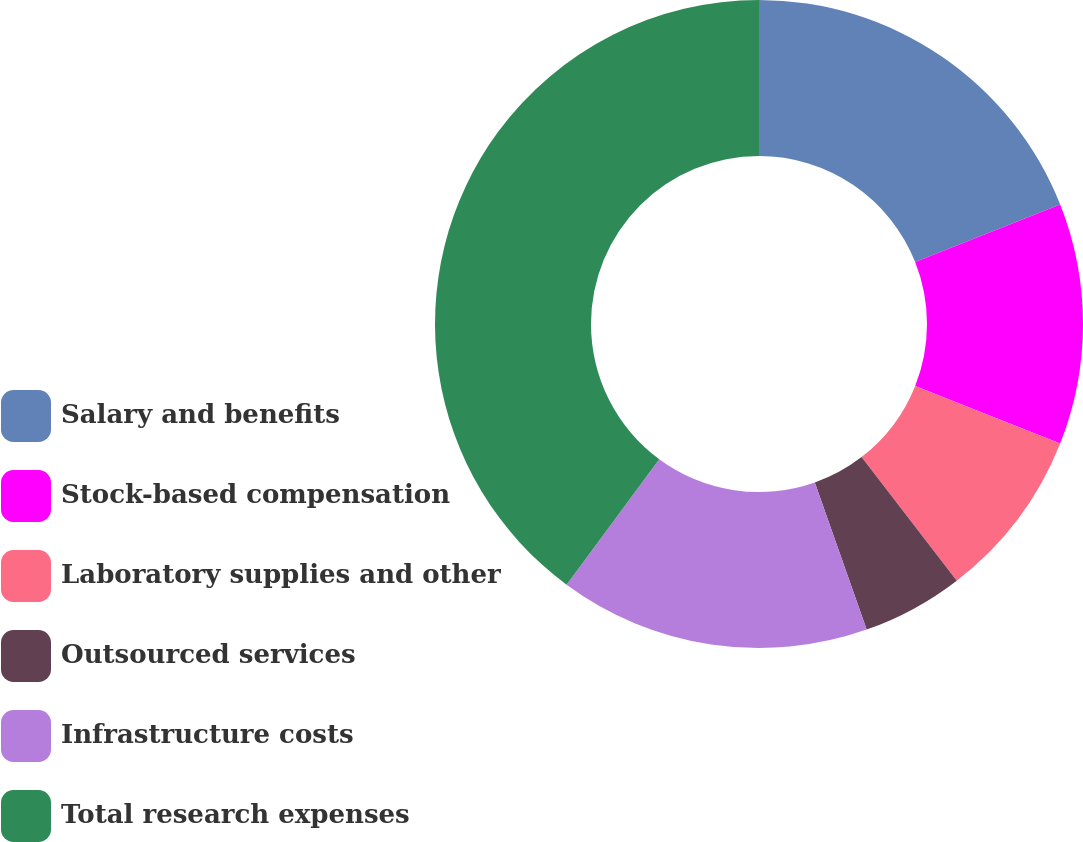<chart> <loc_0><loc_0><loc_500><loc_500><pie_chart><fcel>Salary and benefits<fcel>Stock-based compensation<fcel>Laboratory supplies and other<fcel>Outsourced services<fcel>Infrastructure costs<fcel>Total research expenses<nl><fcel>18.99%<fcel>12.02%<fcel>8.54%<fcel>5.06%<fcel>15.51%<fcel>39.88%<nl></chart> 